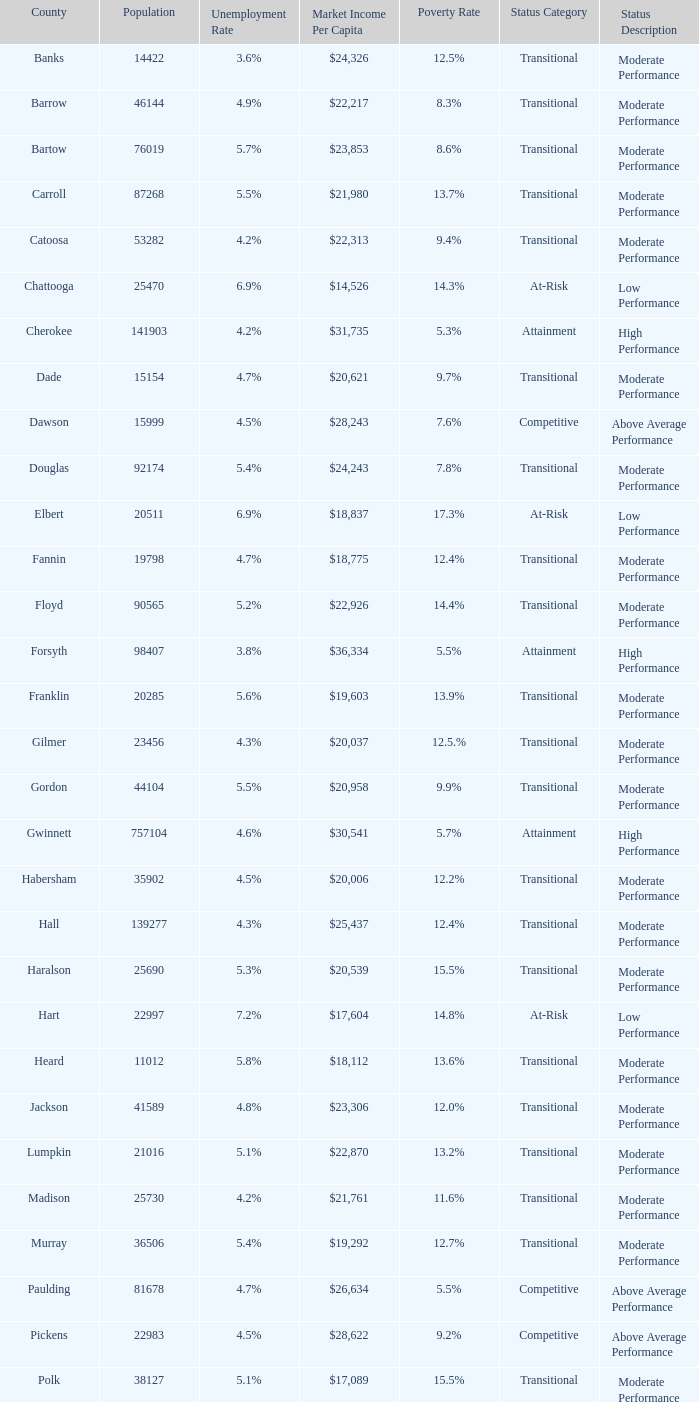What is the status of the county with per capita market income of $24,326? Transitional. 